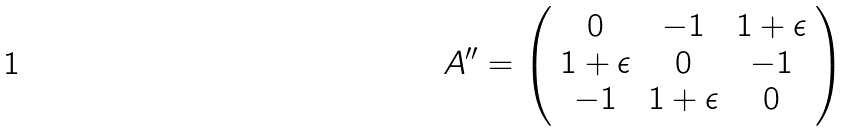Convert formula to latex. <formula><loc_0><loc_0><loc_500><loc_500>A ^ { \prime \prime } = \left ( \begin{array} { c c c } 0 & - 1 & 1 + \epsilon \\ 1 + \epsilon & 0 & - 1 \\ - 1 & 1 + \epsilon & 0 \end{array} \right )</formula> 